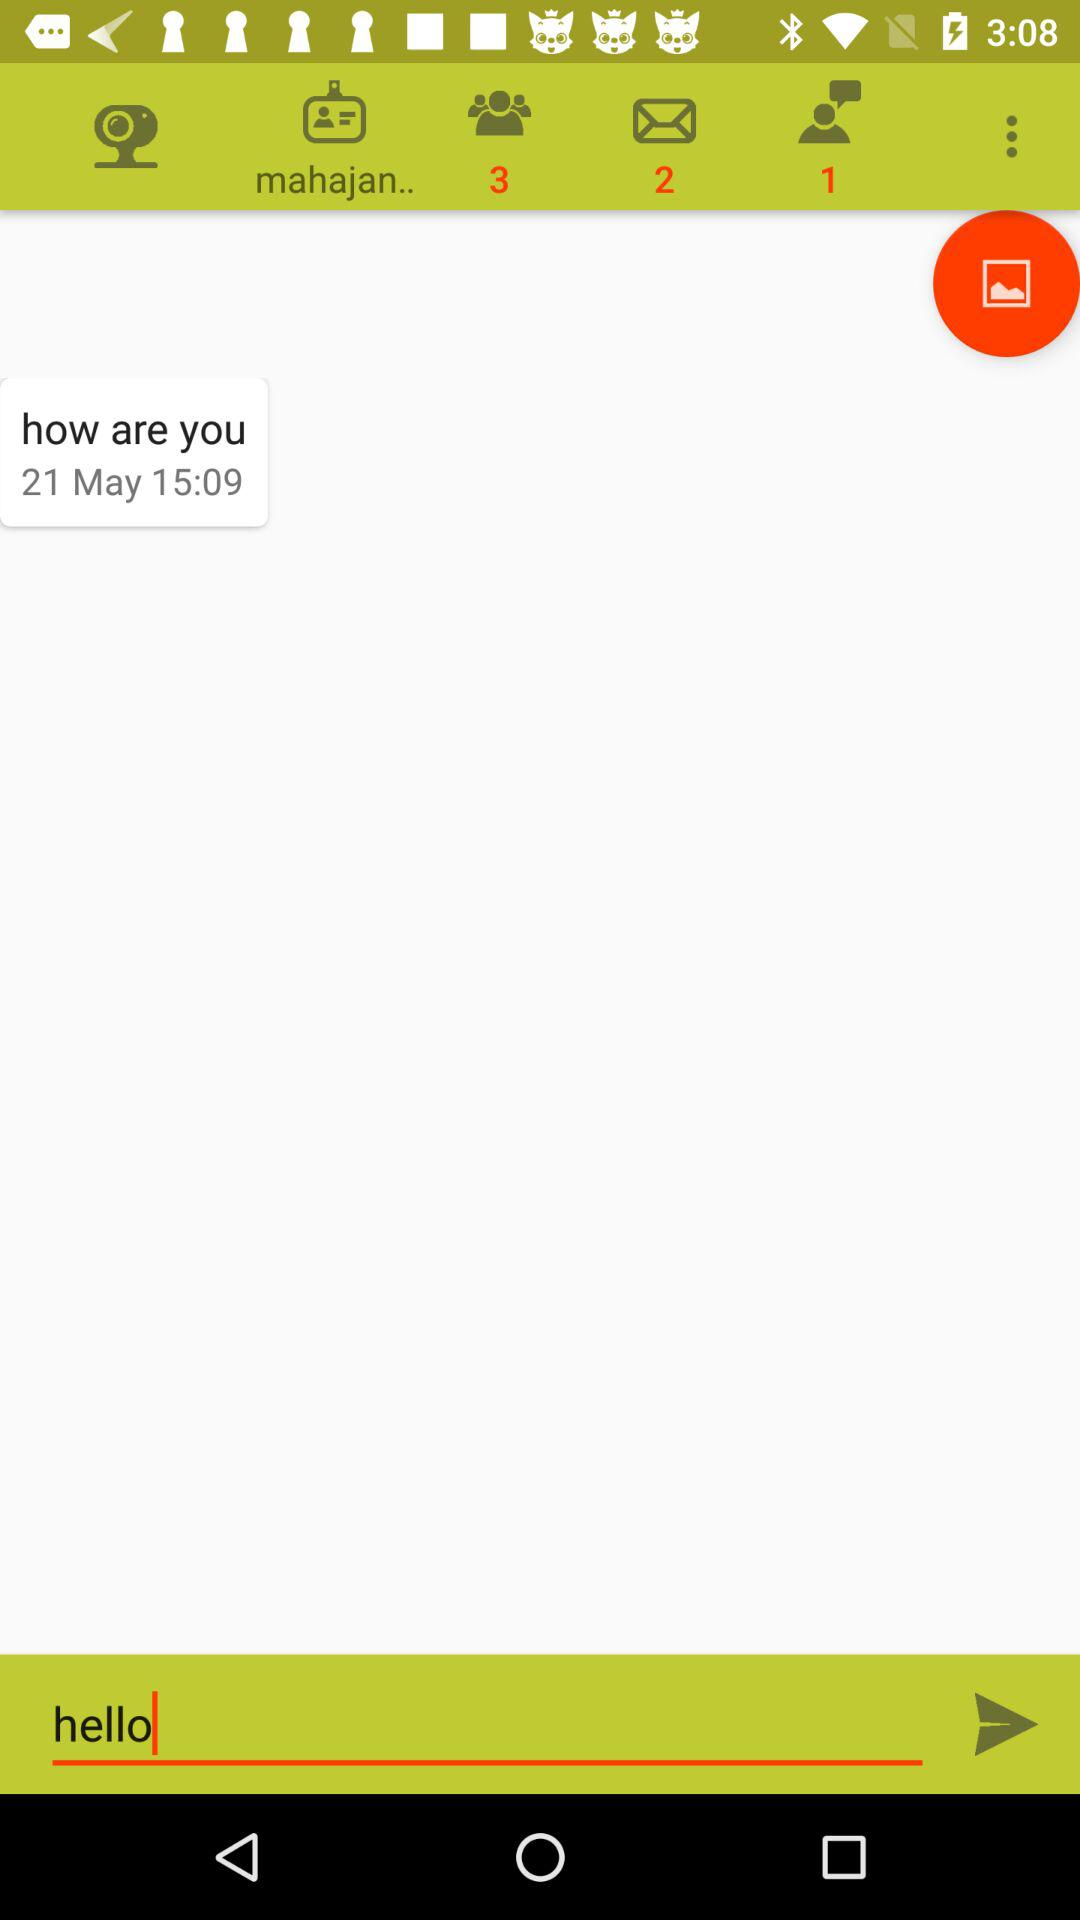What is the given date? The given date is May 21. 